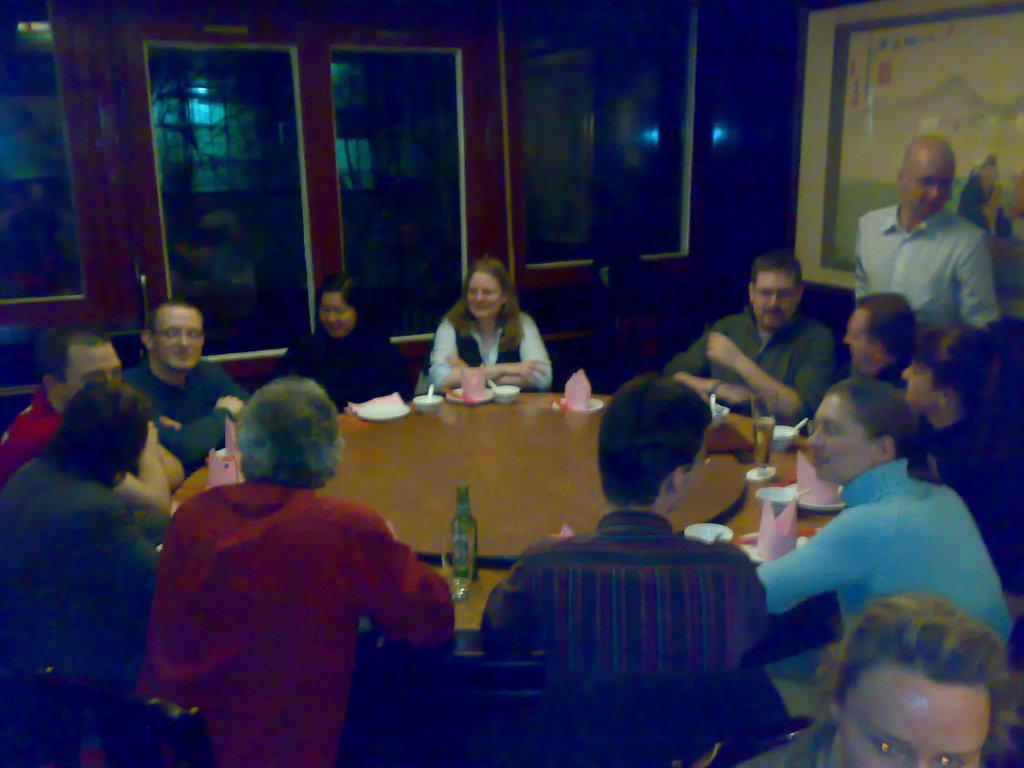Please provide a concise description of this image. In this picture I can see number of people sitting around a table and on the table, I can see a bottle, a glass and other few things. On the right side of this picture, I can see a man standing and on the right bottom corner of this picture, I can see a person's face. In the background I can see the glasses. I can also see an art on the right top of this picture. 